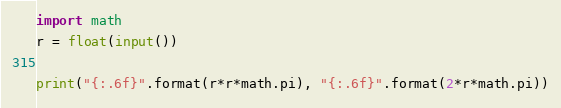Convert code to text. <code><loc_0><loc_0><loc_500><loc_500><_Python_>import math
r = float(input())

print("{:.6f}".format(r*r*math.pi), "{:.6f}".format(2*r*math.pi))</code> 